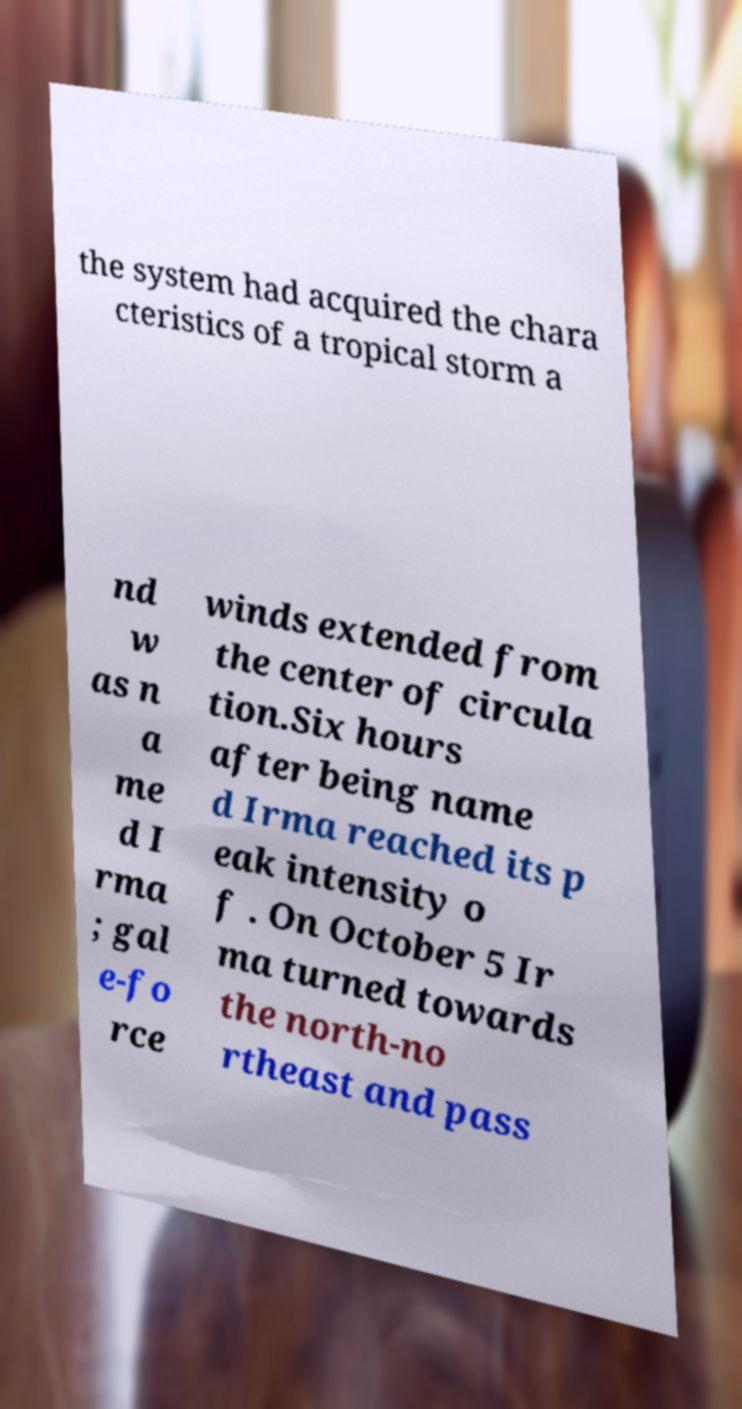What messages or text are displayed in this image? I need them in a readable, typed format. the system had acquired the chara cteristics of a tropical storm a nd w as n a me d I rma ; gal e-fo rce winds extended from the center of circula tion.Six hours after being name d Irma reached its p eak intensity o f . On October 5 Ir ma turned towards the north-no rtheast and pass 